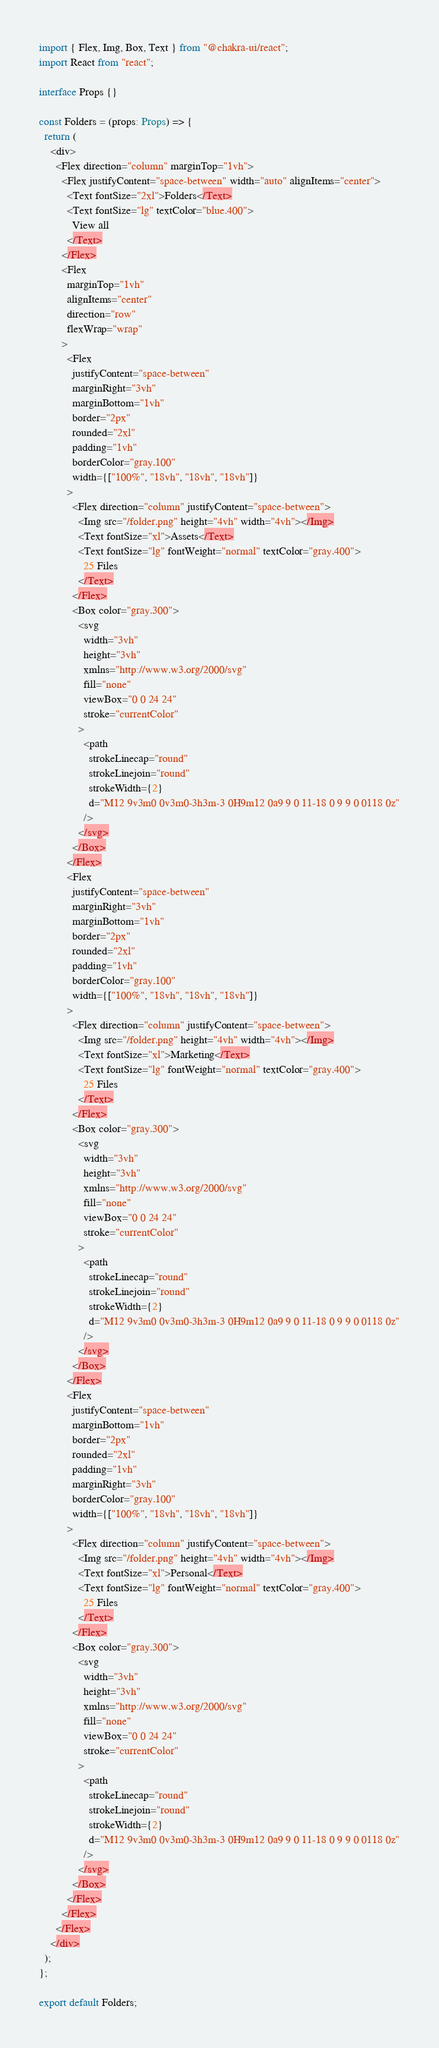Convert code to text. <code><loc_0><loc_0><loc_500><loc_500><_TypeScript_>import { Flex, Img, Box, Text } from "@chakra-ui/react";
import React from "react";

interface Props {}

const Folders = (props: Props) => {
  return (
    <div>
      <Flex direction="column" marginTop="1vh">
        <Flex justifyContent="space-between" width="auto" alignItems="center">
          <Text fontSize="2xl">Folders</Text>
          <Text fontSize="lg" textColor="blue.400">
            View all
          </Text>
        </Flex>
        <Flex
          marginTop="1vh"
          alignItems="center"
          direction="row"
          flexWrap="wrap"
        >
          <Flex
            justifyContent="space-between"
            marginRight="3vh"
            marginBottom="1vh"
            border="2px"
            rounded="2xl"
            padding="1vh"
            borderColor="gray.100"
            width={["100%", "18vh", "18vh", "18vh"]}
          >
            <Flex direction="column" justifyContent="space-between">
              <Img src="/folder.png" height="4vh" width="4vh"></Img>
              <Text fontSize="xl">Assets</Text>
              <Text fontSize="lg" fontWeight="normal" textColor="gray.400">
                25 Files
              </Text>
            </Flex>
            <Box color="gray.300">
              <svg
                width="3vh"
                height="3vh"
                xmlns="http://www.w3.org/2000/svg"
                fill="none"
                viewBox="0 0 24 24"
                stroke="currentColor"
              >
                <path
                  strokeLinecap="round"
                  strokeLinejoin="round"
                  strokeWidth={2}
                  d="M12 9v3m0 0v3m0-3h3m-3 0H9m12 0a9 9 0 11-18 0 9 9 0 0118 0z"
                />
              </svg>
            </Box>
          </Flex>
          <Flex
            justifyContent="space-between"
            marginRight="3vh"
            marginBottom="1vh"
            border="2px"
            rounded="2xl"
            padding="1vh"
            borderColor="gray.100"
            width={["100%", "18vh", "18vh", "18vh"]}
          >
            <Flex direction="column" justifyContent="space-between">
              <Img src="/folder.png" height="4vh" width="4vh"></Img>
              <Text fontSize="xl">Marketing</Text>
              <Text fontSize="lg" fontWeight="normal" textColor="gray.400">
                25 Files
              </Text>
            </Flex>
            <Box color="gray.300">
              <svg
                width="3vh"
                height="3vh"
                xmlns="http://www.w3.org/2000/svg"
                fill="none"
                viewBox="0 0 24 24"
                stroke="currentColor"
              >
                <path
                  strokeLinecap="round"
                  strokeLinejoin="round"
                  strokeWidth={2}
                  d="M12 9v3m0 0v3m0-3h3m-3 0H9m12 0a9 9 0 11-18 0 9 9 0 0118 0z"
                />
              </svg>
            </Box>
          </Flex>
          <Flex
            justifyContent="space-between"
            marginBottom="1vh"
            border="2px"
            rounded="2xl"
            padding="1vh"
            marginRight="3vh"
            borderColor="gray.100"
            width={["100%", "18vh", "18vh", "18vh"]}
          >
            <Flex direction="column" justifyContent="space-between">
              <Img src="/folder.png" height="4vh" width="4vh"></Img>
              <Text fontSize="xl">Personal</Text>
              <Text fontSize="lg" fontWeight="normal" textColor="gray.400">
                25 Files
              </Text>
            </Flex>
            <Box color="gray.300">
              <svg
                width="3vh"
                height="3vh"
                xmlns="http://www.w3.org/2000/svg"
                fill="none"
                viewBox="0 0 24 24"
                stroke="currentColor"
              >
                <path
                  strokeLinecap="round"
                  strokeLinejoin="round"
                  strokeWidth={2}
                  d="M12 9v3m0 0v3m0-3h3m-3 0H9m12 0a9 9 0 11-18 0 9 9 0 0118 0z"
                />
              </svg>
            </Box>
          </Flex>
        </Flex>
      </Flex>
    </div>
  );
};

export default Folders;
</code> 